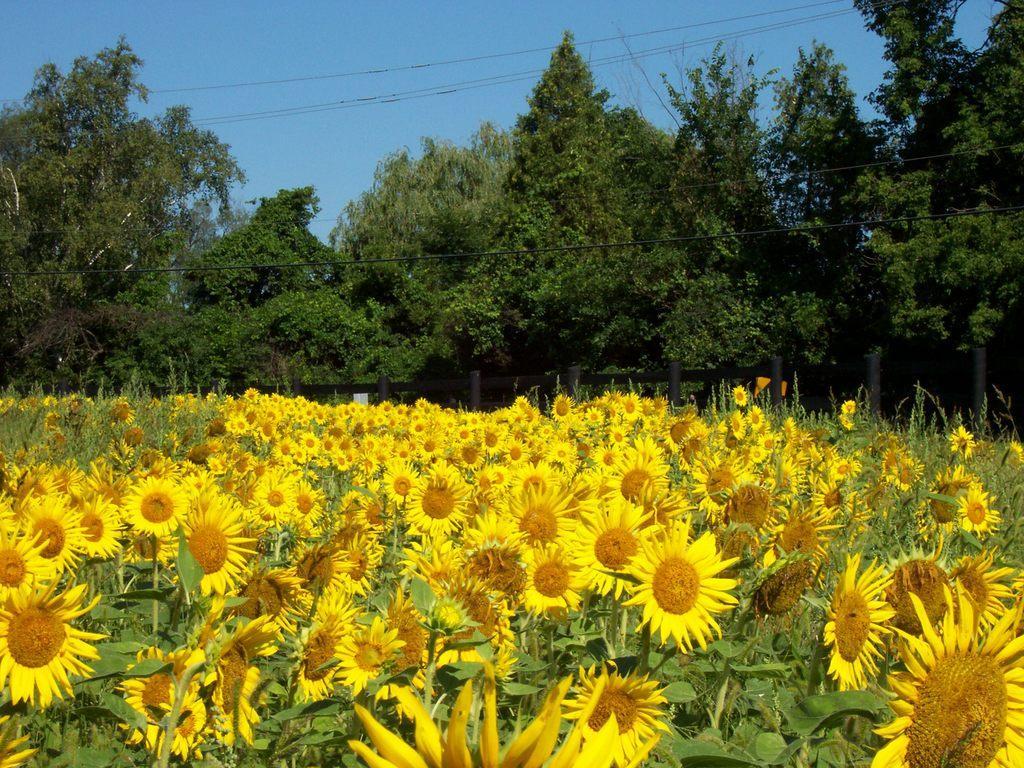Please provide a concise description of this image. In this image I can see crop of sunflowers and I can see trees and electric wires in the center of the image and I can see the sky at the top of the image. 